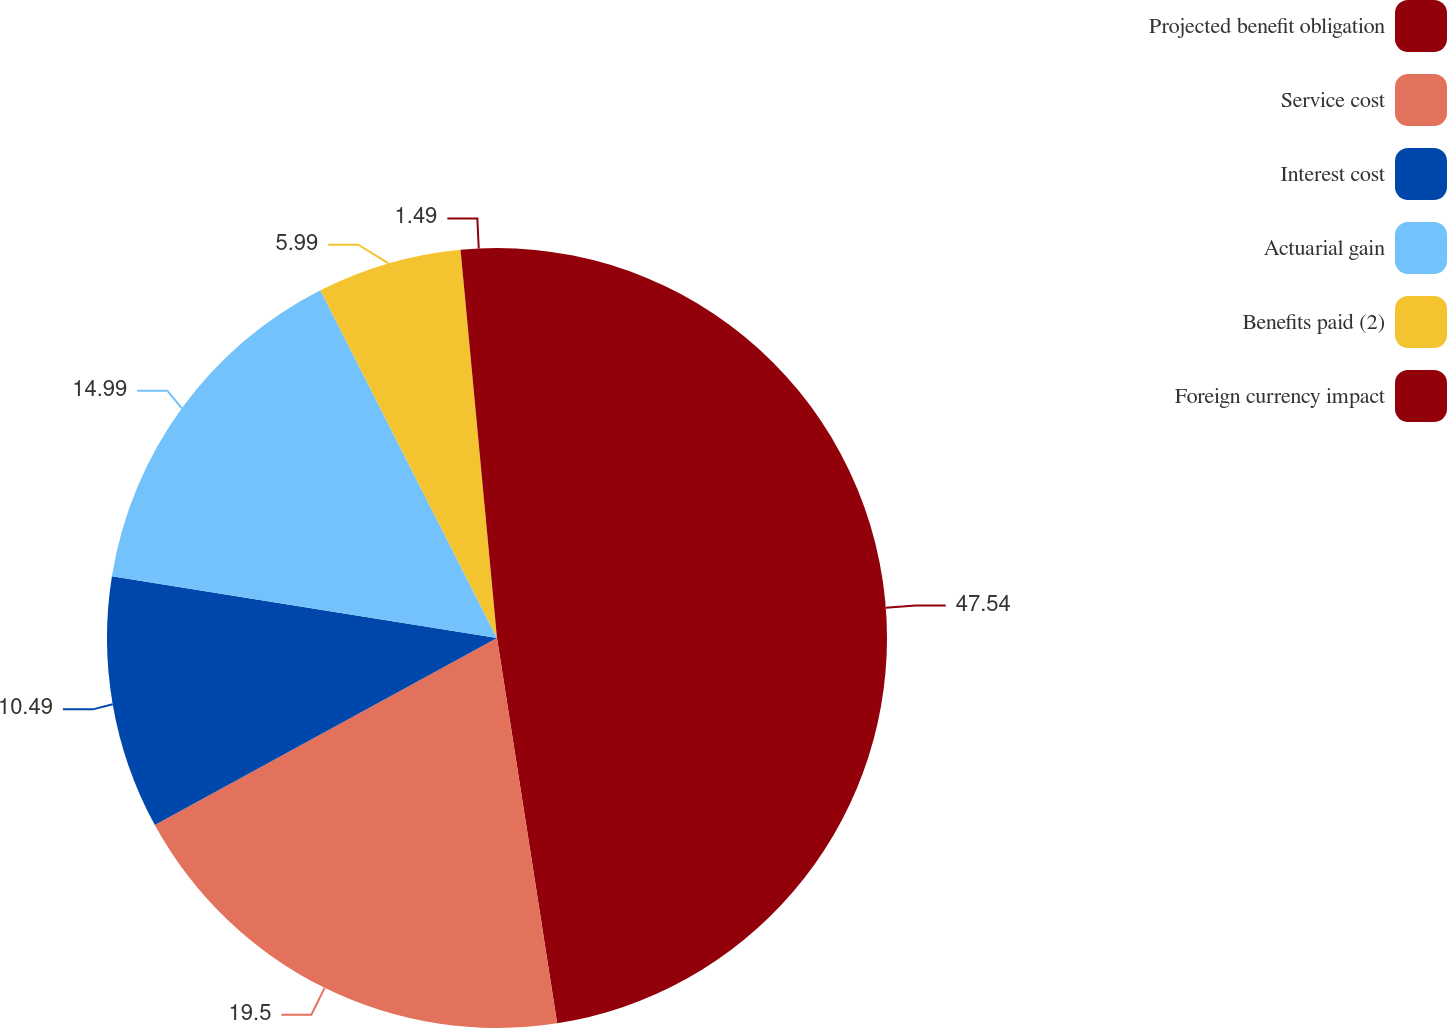<chart> <loc_0><loc_0><loc_500><loc_500><pie_chart><fcel>Projected benefit obligation<fcel>Service cost<fcel>Interest cost<fcel>Actuarial gain<fcel>Benefits paid (2)<fcel>Foreign currency impact<nl><fcel>47.53%<fcel>19.5%<fcel>10.49%<fcel>14.99%<fcel>5.99%<fcel>1.49%<nl></chart> 